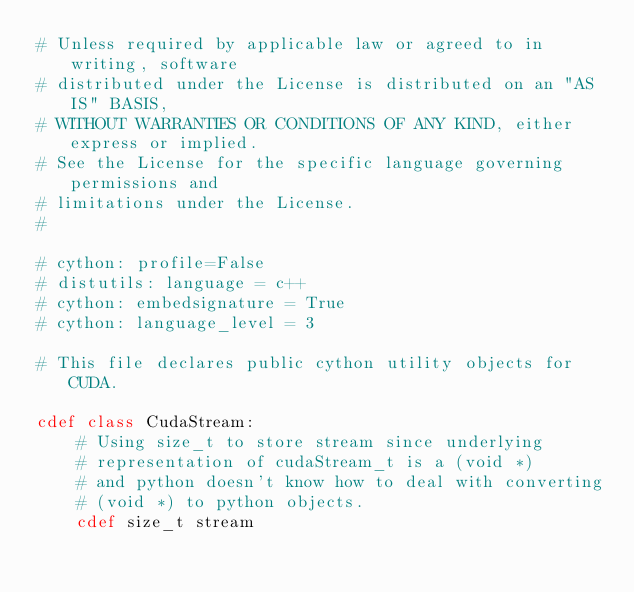<code> <loc_0><loc_0><loc_500><loc_500><_Cython_># Unless required by applicable law or agreed to in writing, software
# distributed under the License is distributed on an "AS IS" BASIS,
# WITHOUT WARRANTIES OR CONDITIONS OF ANY KIND, either express or implied.
# See the License for the specific language governing permissions and
# limitations under the License.
#

# cython: profile=False
# distutils: language = c++
# cython: embedsignature = True
# cython: language_level = 3

# This file declares public cython utility objects for CUDA.

cdef class CudaStream:
    # Using size_t to store stream since underlying
    # representation of cudaStream_t is a (void *)
    # and python doesn't know how to deal with converting
    # (void *) to python objects.
    cdef size_t stream
</code> 